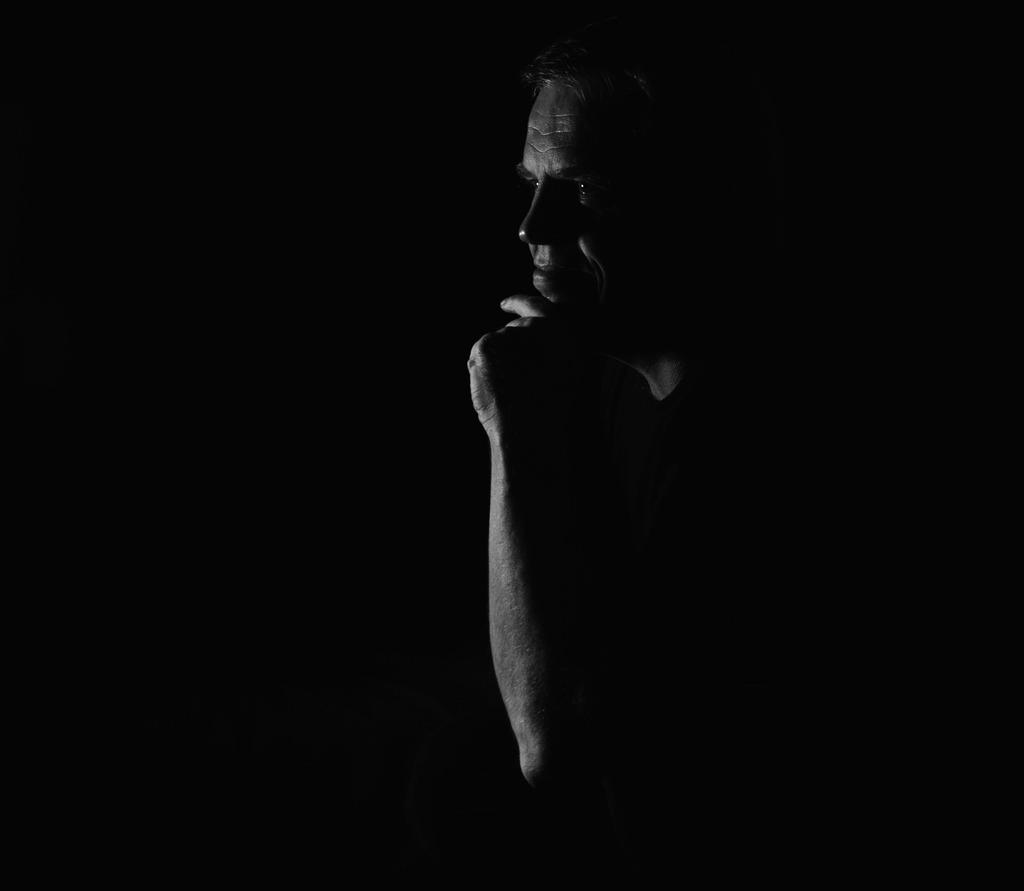Who is present in the image? There is a man in the image. What can be observed about the background of the image? The background of the image is dark. What type of rod is the man holding in the image? There is no rod present in the image; only the man and the dark background can be observed. 